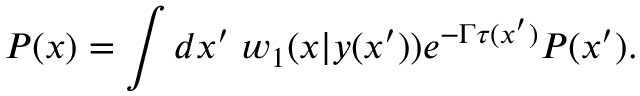Convert formula to latex. <formula><loc_0><loc_0><loc_500><loc_500>P ( x ) = \int d x ^ { \prime } \, w _ { 1 } ( x | y ( x ^ { \prime } ) ) e ^ { - \Gamma \tau ( x ^ { \prime } ) } P ( x ^ { \prime } ) .</formula> 